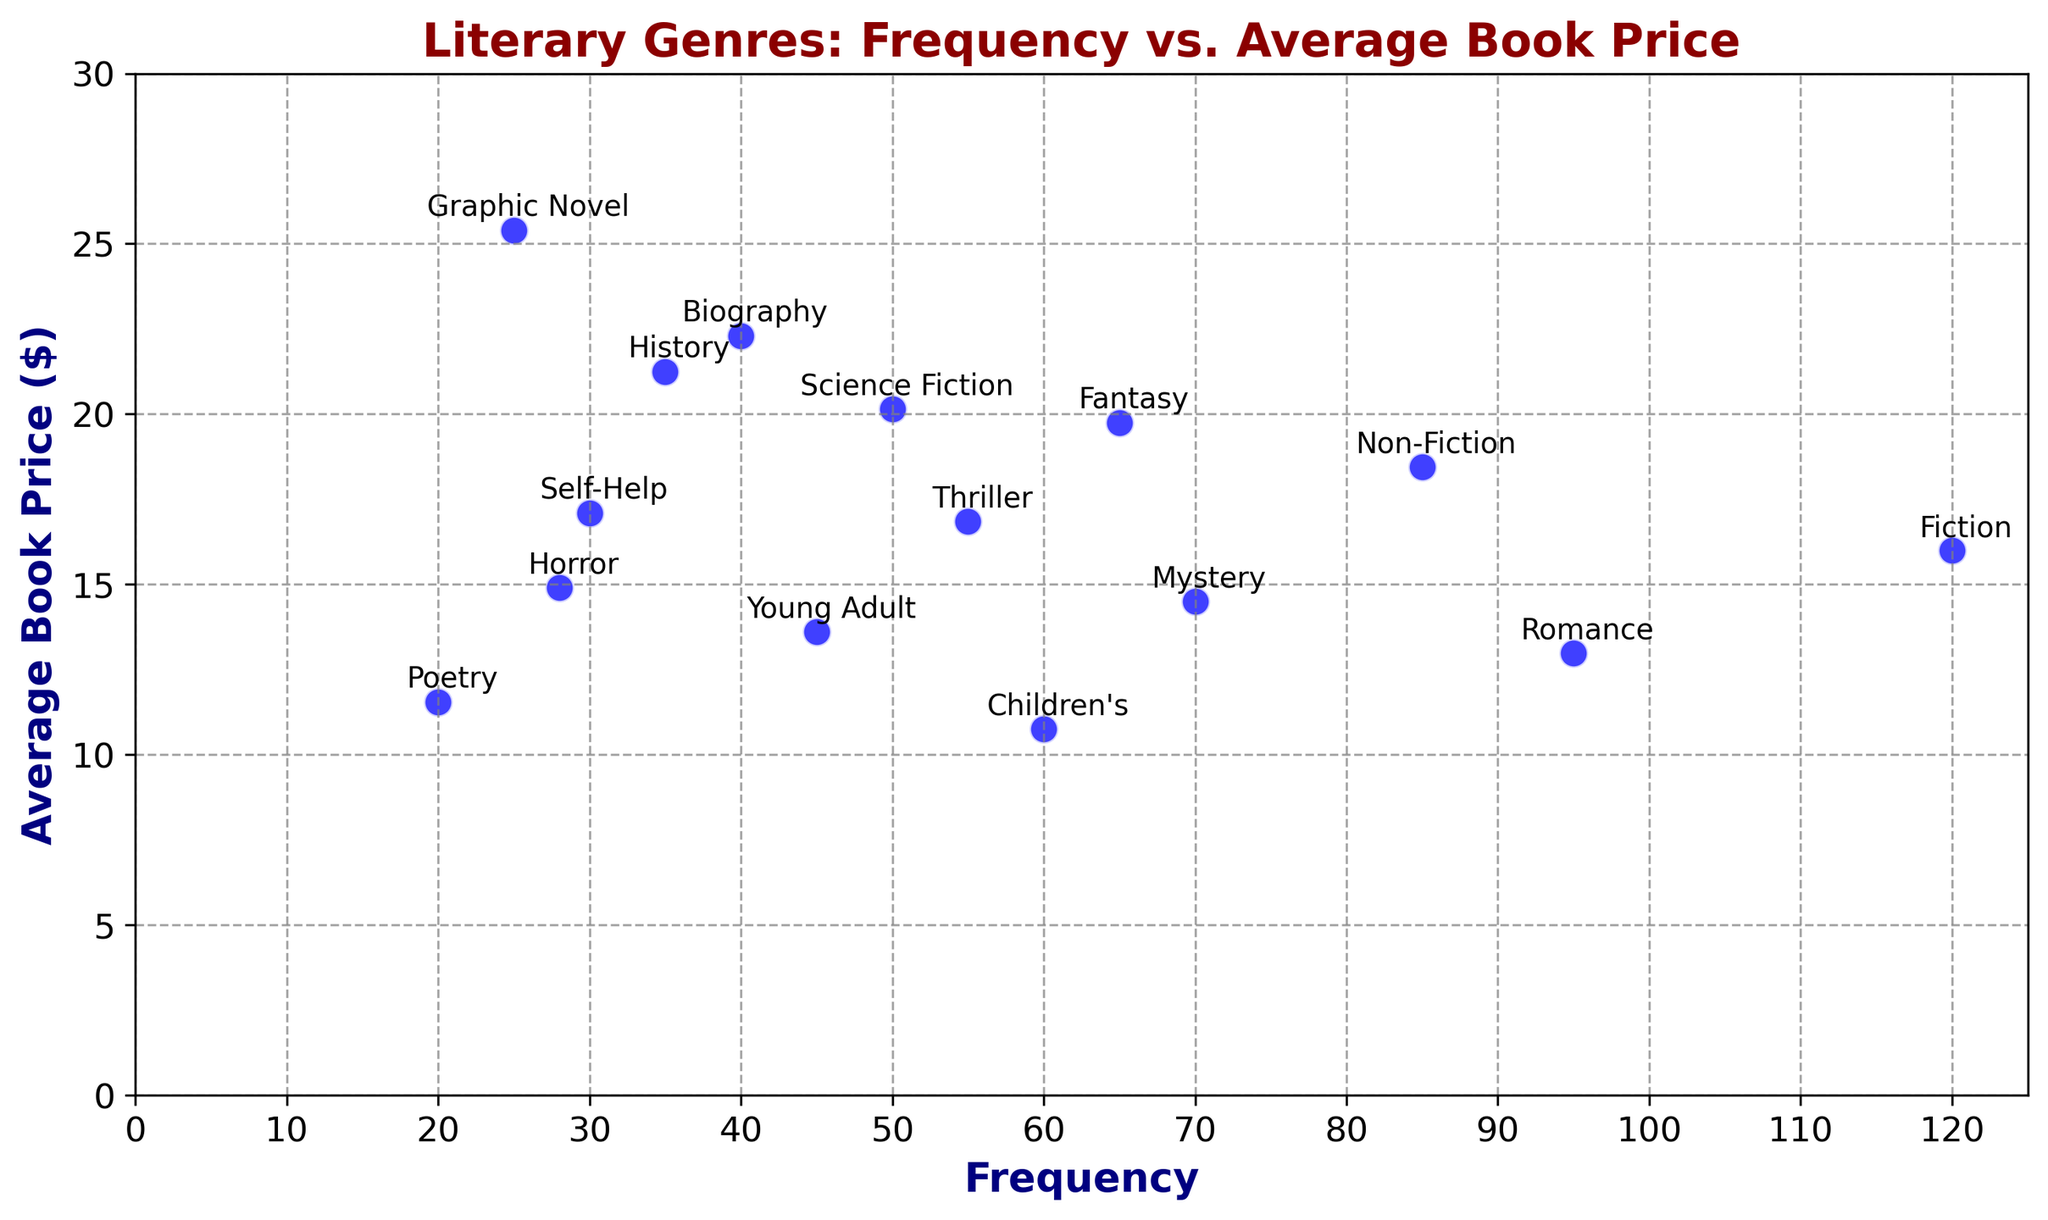What genre has the highest average book price? The Graphic Novel genre has the highest average book price, as indicated by its position along the y-axis at $25.40.
Answer: Graphic Novel What is the difference in average book price between Fiction and Non-Fiction genres? The Fiction genre has an average book price of $15.99, and the Non-Fiction genre has an average book price of $18.45. Subtracting these values yields $18.45 - $15.99 = $2.46.
Answer: $2.46 Which genre has the lowest frequency and what is its average book price? The genre with the lowest frequency is Poetry, with a frequency of 20. Its average book price is $11.55, as shown by its position along the y-axis.
Answer: Poetry, $11.55 What is the total frequency of genres with an average book price greater than $20? The genres with an average book price greater than $20 are Science Fiction, Biography, History, and Graphic Novel, with frequencies of 50, 40, 35, and 25, respectively. Summing these frequencies gives 50 + 40 + 35 + 25 = 150.
Answer: 150 How does the frequency of Mystery compare to that of Thriller? The frequency of Mystery is 70, while the frequency of Thriller is 55. Since 70 > 55, Mystery has a higher frequency than Thriller.
Answer: Mystery has a higher frequency Which genres have a higher average book price than Fiction? Fiction has an average book price of $15.99. The genres with higher average book prices are Non-Fiction ($18.45), Science Fiction ($20.15), Fantasy ($19.75), Thriller ($16.85), Biography ($22.30), Self-Help ($17.10), History ($21.25), and Graphic Novel ($25.40).
Answer: Non-Fiction, Science Fiction, Fantasy, Thriller, Biography, Self-Help, History, Graphic Novel What is the average book price for genres with a frequency less than 35? The genres with a frequency less than 35 are Self-Help ($17.10), Graphic Novel ($25.40), Poetry ($11.55), and Horror ($14.90). Calculating the average gives (17.10 + 25.40 + 11.55 + 14.90) / 4 = 17.2375.
Answer: $17.24 Which genres are annotated close to each other, suggesting similar frequency and average book price? Mystery and Thriller are annotated close to each other, suggesting they have similar frequency (70 and 55, respectively) and average book price ($14.50 and $16.85, respectively).
Answer: Mystery and Thriller 